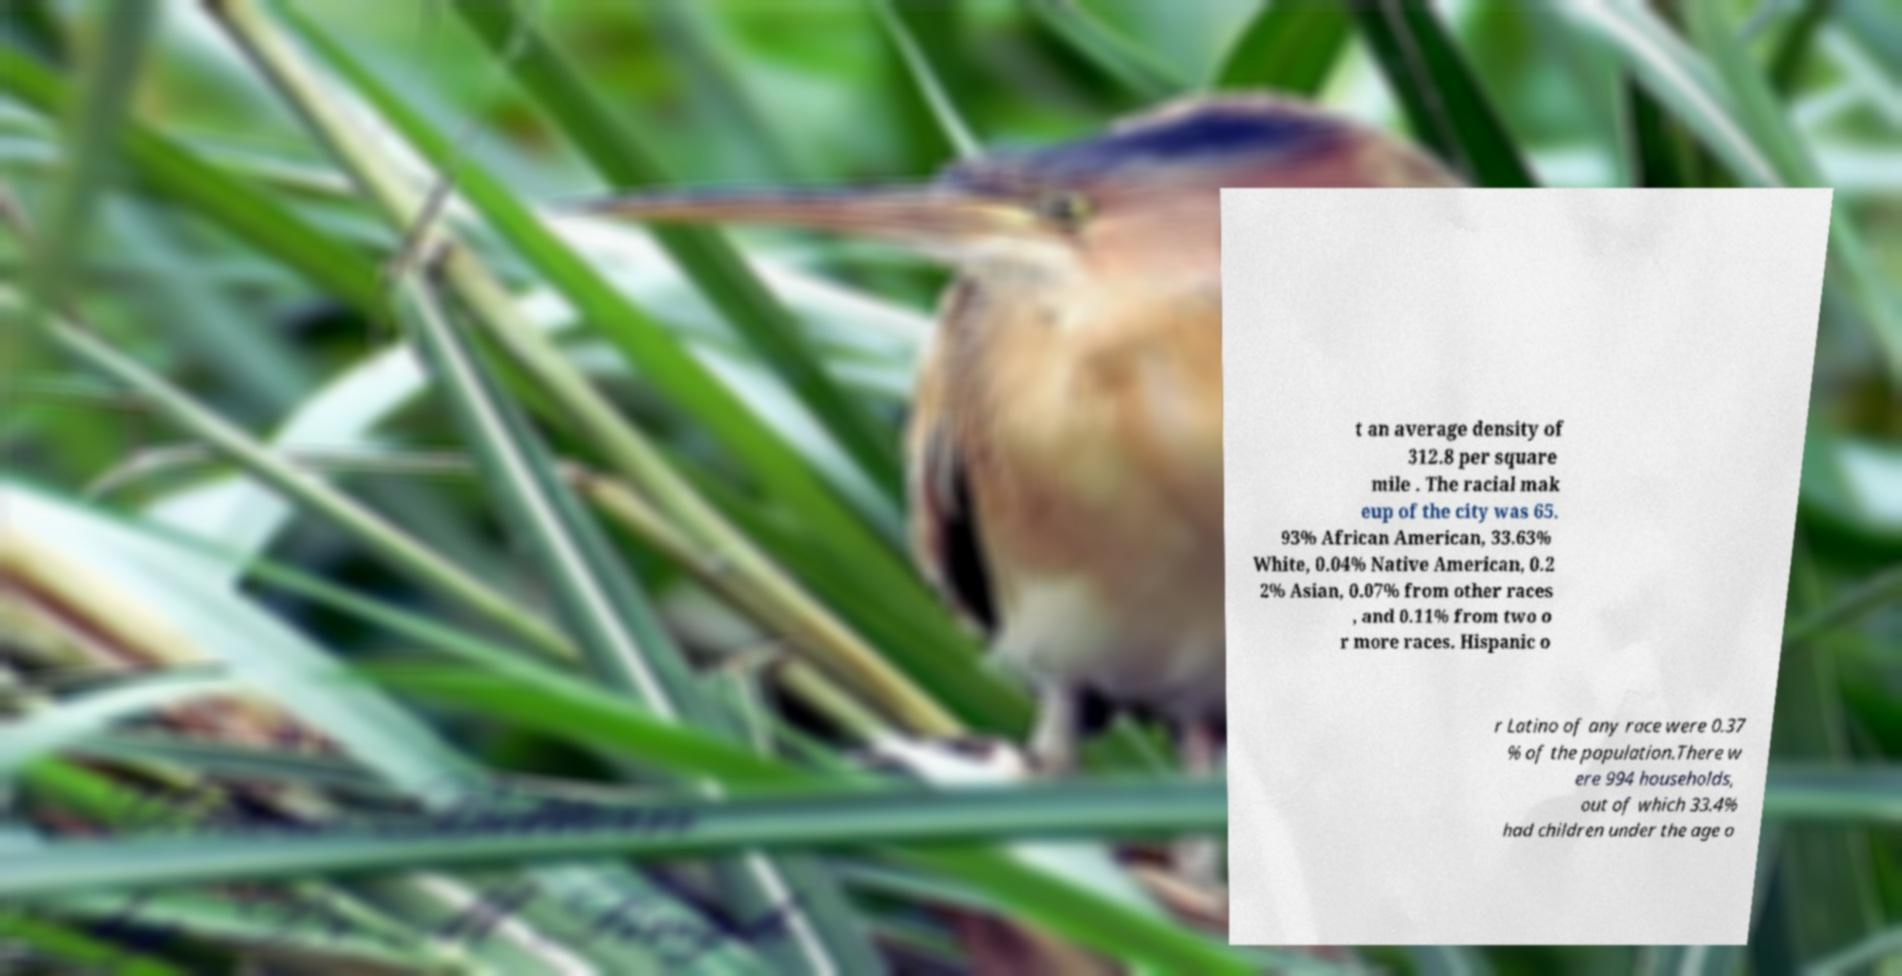Can you accurately transcribe the text from the provided image for me? t an average density of 312.8 per square mile . The racial mak eup of the city was 65. 93% African American, 33.63% White, 0.04% Native American, 0.2 2% Asian, 0.07% from other races , and 0.11% from two o r more races. Hispanic o r Latino of any race were 0.37 % of the population.There w ere 994 households, out of which 33.4% had children under the age o 